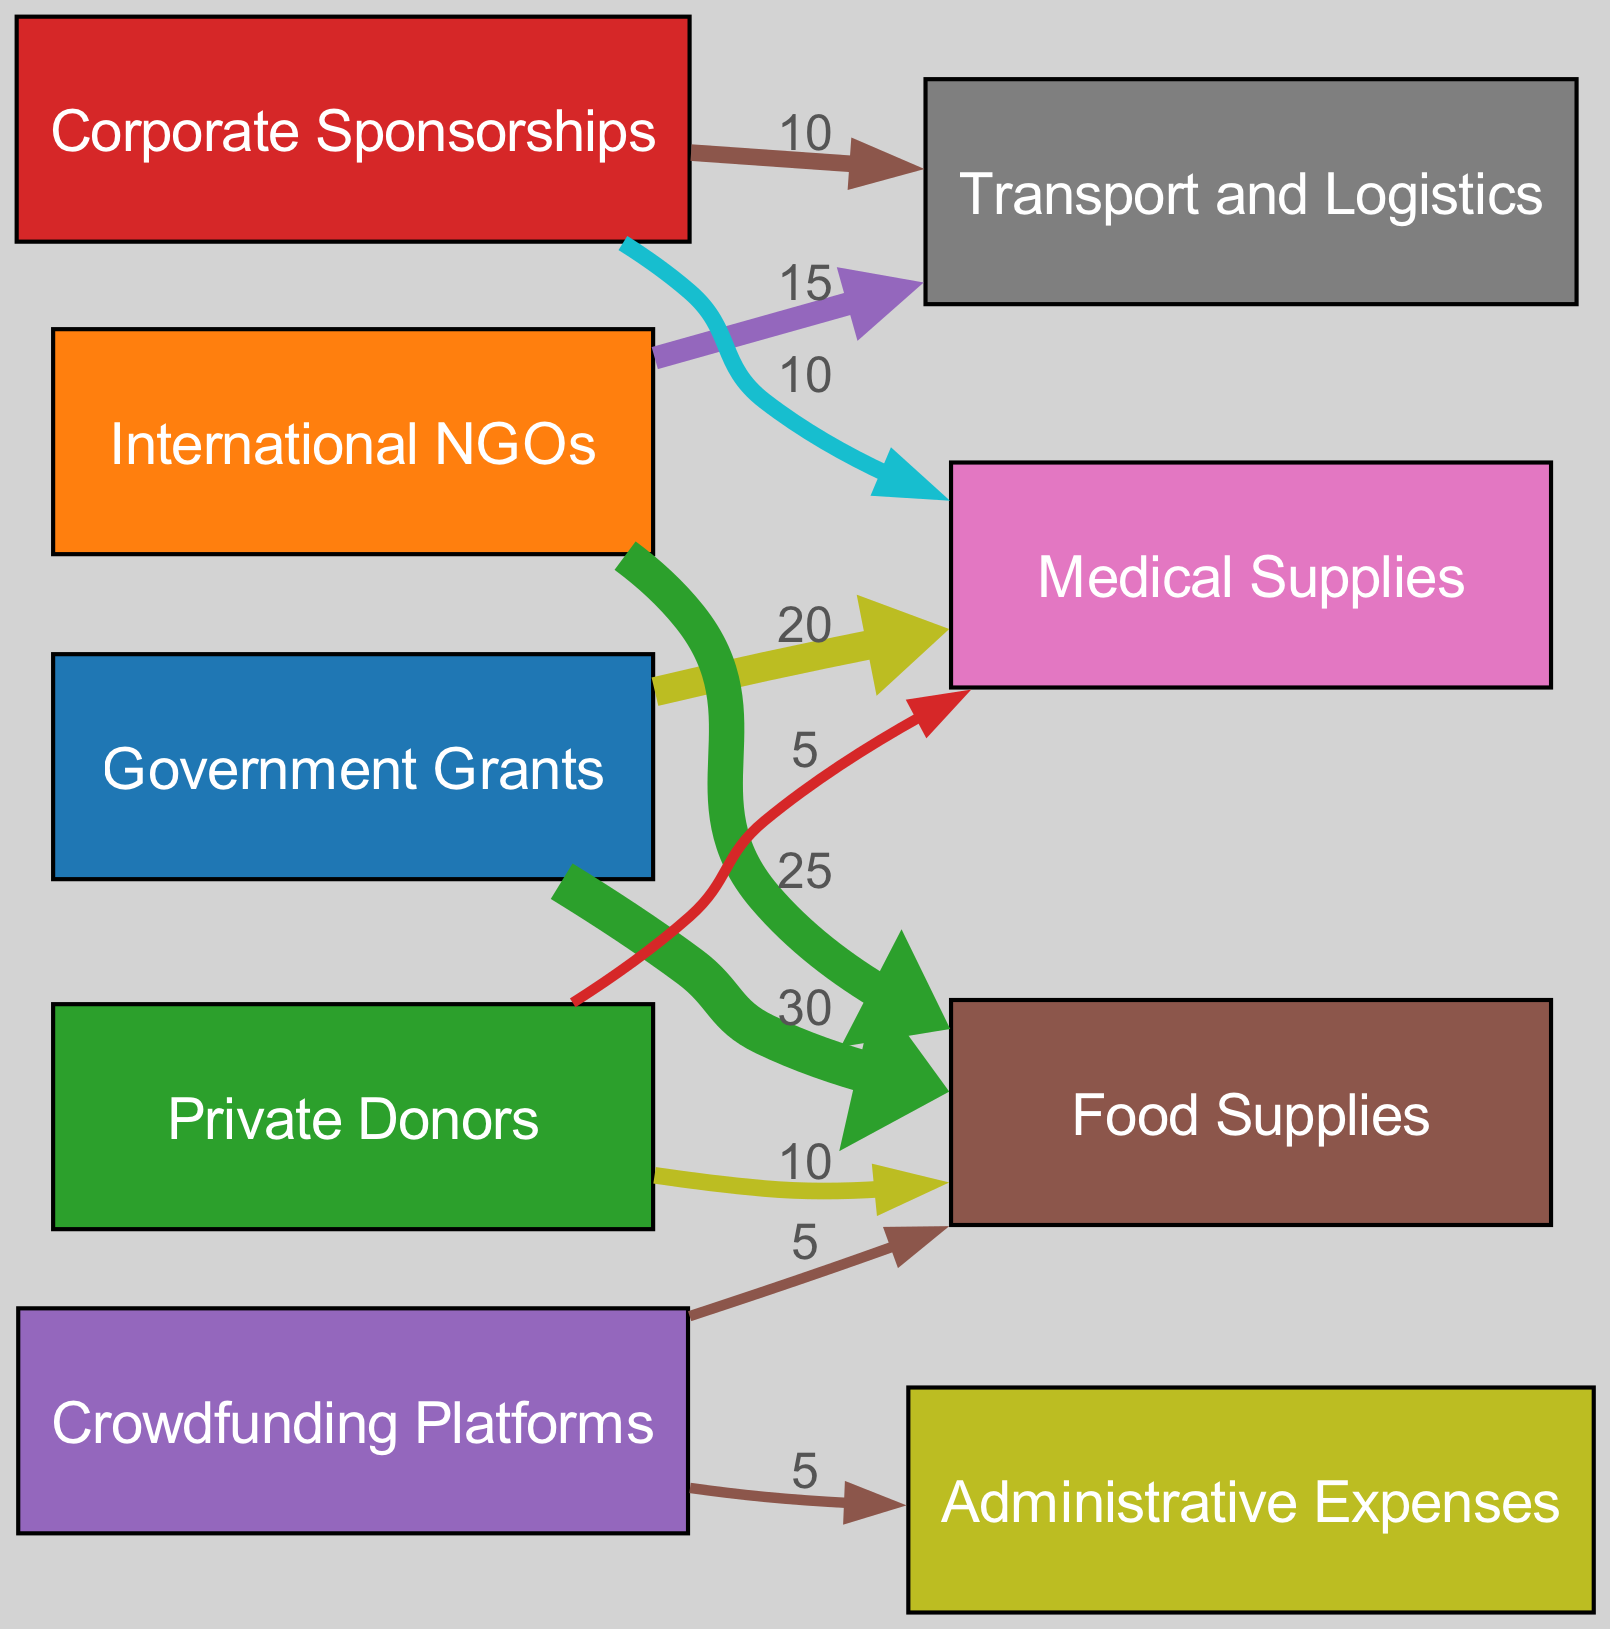What is the total value of funding from Government Grants? According to the links, the Government Grants provide funding worth 30 for Food Supplies and 20 for Medical Supplies. Therefore, the total value is calculated as 30 + 20 = 50.
Answer: 50 Which node receives the least funding? Examining the links for each node's incoming values, Crowdfunding Platforms provide 5 for Food Supplies and 5 for Administrative Expenses, while Private Donors provide 5 for Medical Supplies. Since they receive the same minimum value of 5 each, both are tied as the least funded.
Answer: Crowdfunding Platforms, Private Donors What is the combined value of funding for Food Supplies? The sources for Food Supplies are Government Grants (30), International NGOs (25), Private Donors (10), and Crowdfunding Platforms (5). Adding these gives us 30 + 25 + 10 + 5 = 70 for Food Supplies.
Answer: 70 How many total funding sources are contributing to Medical Supplies? The sources providing funding for Medical Supplies, as seen in the links, are Government Grants (20), Private Donors (5), and Corporate Sponsorships (10). Therefore, there are a total of 3 sources that contribute to Medical Supplies.
Answer: 3 What is the total value allocated to Transport and Logistics? Transport and Logistics receives funding from International NGOs (15) and Corporate Sponsorships (10). The total value for Transport and Logistics is 15 + 10 = 25.
Answer: 25 Which source contribution has the highest single value? By examining the values linked to each source, Government Grants contributes 30 to Food Supplies, which is the highest single value compared to other sources.
Answer: 30 What proportion of the total funding from International NGOs is allocated to Food Supplies? International NGOs provide a total of 40 (25 for Food Supplies and 15 for Transport). The proportion allocated to Food Supplies is calculated as (25 / 40) * 100 = 62.5%.
Answer: 62.5% Which source has allocations to both Transport and Logistics and Medical Supplies? Corporate Sponsorships are linked to both Transport and Logistics (10) and Medical Supplies (10). Thus, Corporate Sponsorships is the only source with allocations to both categories.
Answer: Corporate Sponsorships How many nodes represent funding types in the diagram? The funding types represented in the nodes are Government Grants, International NGOs, Private Donors, Corporate Sponsorships, and Crowdfunding Platforms. Thus, there are a total of 5 funding type nodes.
Answer: 5 